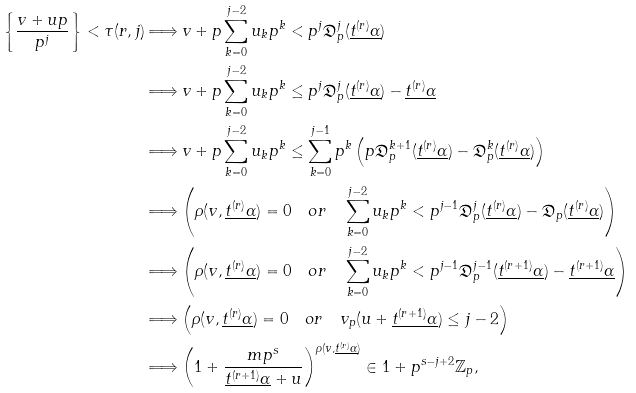Convert formula to latex. <formula><loc_0><loc_0><loc_500><loc_500>\left \{ \frac { v + u p } { p ^ { j } } \right \} < \tau ( r , j ) & \Longrightarrow v + p \sum _ { k = 0 } ^ { j - 2 } u _ { k } p ^ { k } < p ^ { j } \mathfrak { D } _ { p } ^ { j } ( \underline { t ^ { ( r ) } \alpha } ) \\ & \Longrightarrow v + p \sum _ { k = 0 } ^ { j - 2 } u _ { k } p ^ { k } \leq p ^ { j } \mathfrak { D } _ { p } ^ { j } ( \underline { t ^ { ( r ) } \alpha } ) - \underline { t ^ { ( r ) } \alpha } \\ & \Longrightarrow v + p \sum _ { k = 0 } ^ { j - 2 } u _ { k } p ^ { k } \leq \sum _ { k = 0 } ^ { j - 1 } p ^ { k } \left ( p \mathfrak { D } _ { p } ^ { k + 1 } ( \underline { t ^ { ( r ) } \alpha } ) - \mathfrak { D } _ { p } ^ { k } ( \underline { t ^ { ( r ) } \alpha } ) \right ) \\ & \Longrightarrow \left ( \rho ( v , \underline { t ^ { ( r ) } \alpha } ) = 0 \quad o r \quad \sum _ { k = 0 } ^ { j - 2 } u _ { k } p ^ { k } < p ^ { j - 1 } \mathfrak { D } _ { p } ^ { j } ( \underline { t ^ { ( r ) } \alpha } ) - \mathfrak { D } _ { p } ( \underline { t ^ { ( r ) } \alpha } ) \right ) \\ & \Longrightarrow \left ( \rho ( v , \underline { t ^ { ( r ) } \alpha } ) = 0 \quad o r \quad \sum _ { k = 0 } ^ { j - 2 } u _ { k } p ^ { k } < p ^ { j - 1 } \mathfrak { D } _ { p } ^ { j - 1 } ( \underline { t ^ { ( r + 1 ) } \alpha } ) - \underline { t ^ { ( r + 1 ) } \alpha } \right ) \\ & \Longrightarrow \left ( \rho ( v , \underline { t ^ { ( r ) } \alpha } ) = 0 \quad o r \quad v _ { p } ( u + \underline { t ^ { ( r + 1 ) } \alpha } ) \leq j - 2 \right ) \\ & \Longrightarrow \left ( 1 + \frac { m p ^ { s } } { \underline { t ^ { ( r + 1 ) } \alpha } + u } \right ) ^ { \rho ( v , \underline { t ^ { ( r ) } \alpha } ) } \in 1 + p ^ { s - j + 2 } \mathbb { Z } _ { p } ,</formula> 